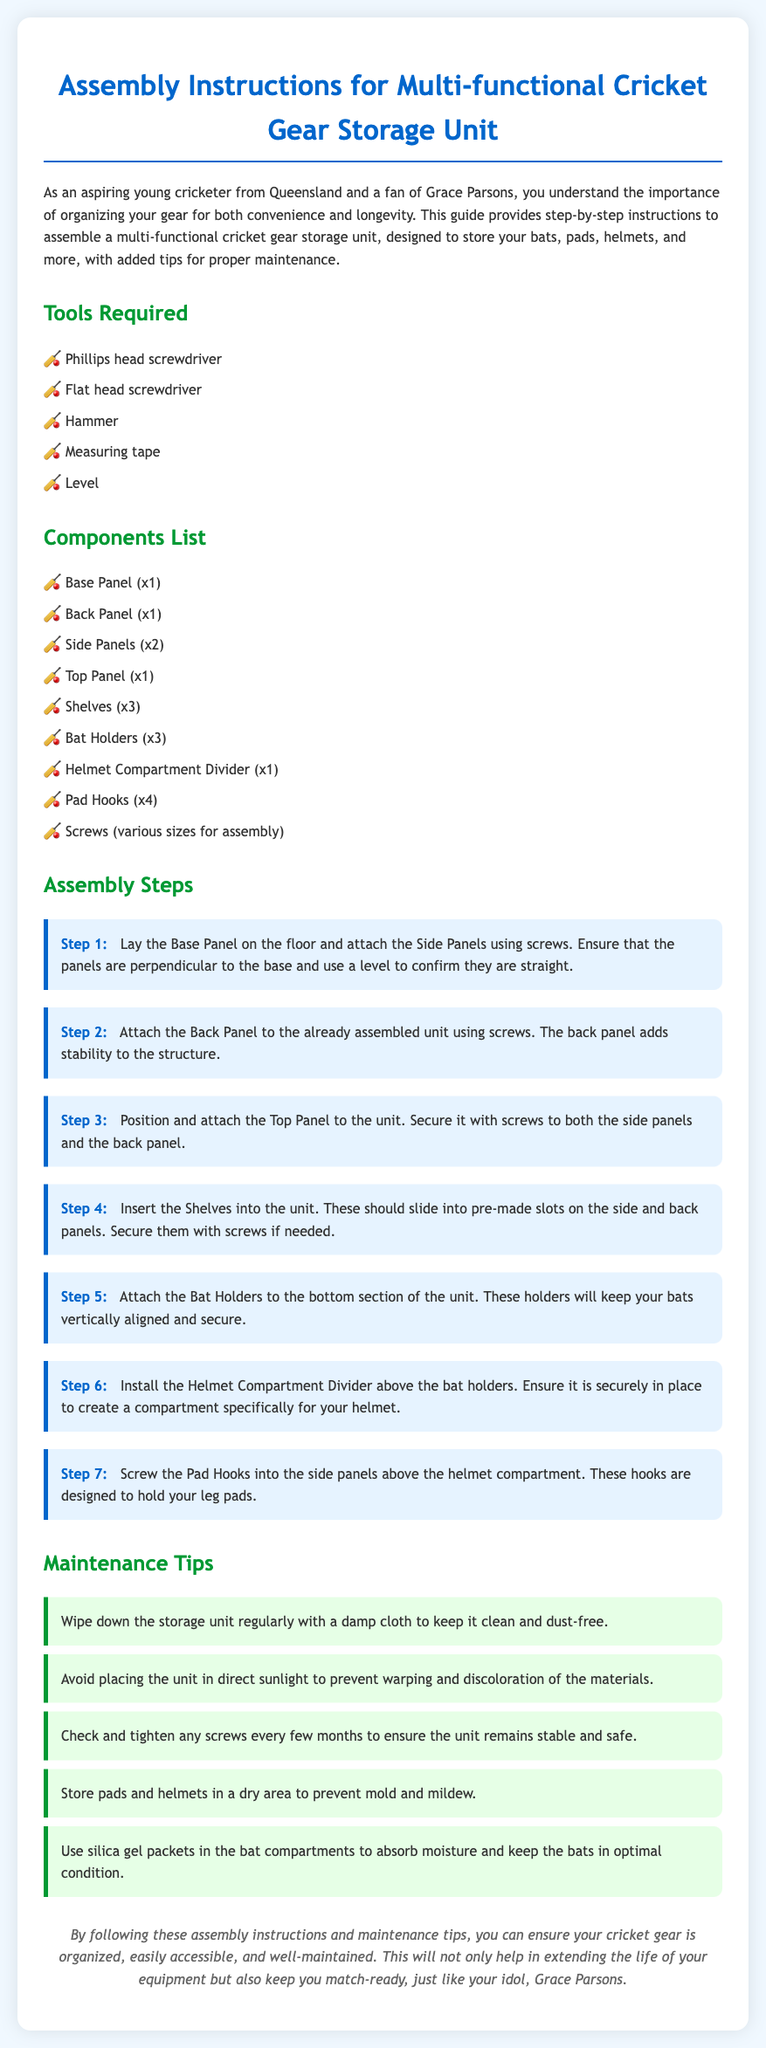what is the title of the document? The title of the document is stated at the beginning and indicates the content of the guide.
Answer: Assembly Instructions for Multi-functional Cricket Gear Storage Unit how many side panels are included? The document lists the components and specifies the number of side panels.
Answer: 2 what tool is required for screws? The tools required are mentioned, including one specifically for screws.
Answer: Phillips head screwdriver which compartment is above the bat holders? The assembly steps describe the position of different compartments in relation to each other.
Answer: Helmet Compartment Divider how many maintenance tips are provided? The document includes a section dedicated to maintenance tips with several listed.
Answer: 5 what should be used to maintain moisture in bat compartments? The maintenance tips suggest a specific item to help manage moisture levels.
Answer: Silica gel packets what color is the step background? The document describes the visual characteristics of the steps in the assembly instructions.
Answer: Light blue what is the first step in the assembly process? The assembly steps outline a sequence, starting with the initial action for setup.
Answer: Lay the Base Panel on the floor what is advised to avoid for the storage unit? The maintenance section provides advice on care and placement regarding specific conditions.
Answer: Direct sunlight 